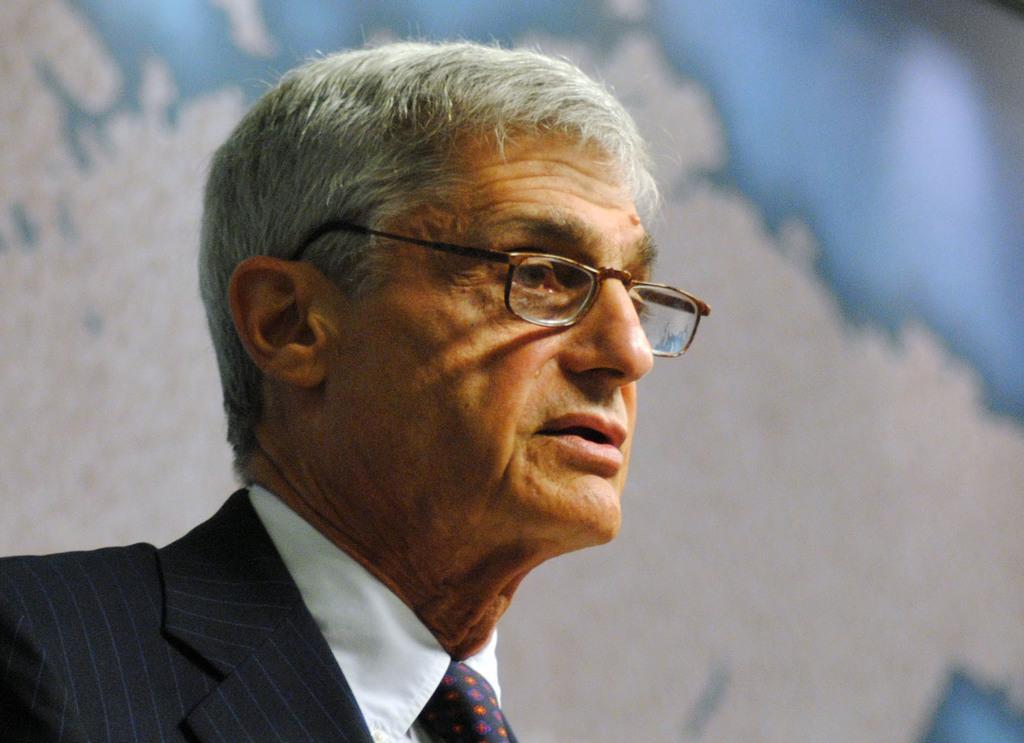How would you summarize this image in a sentence or two? In this image I can see a person wearing white shirt, black blazer and spectacles. I can see the white and blue colored background which is blurry. 